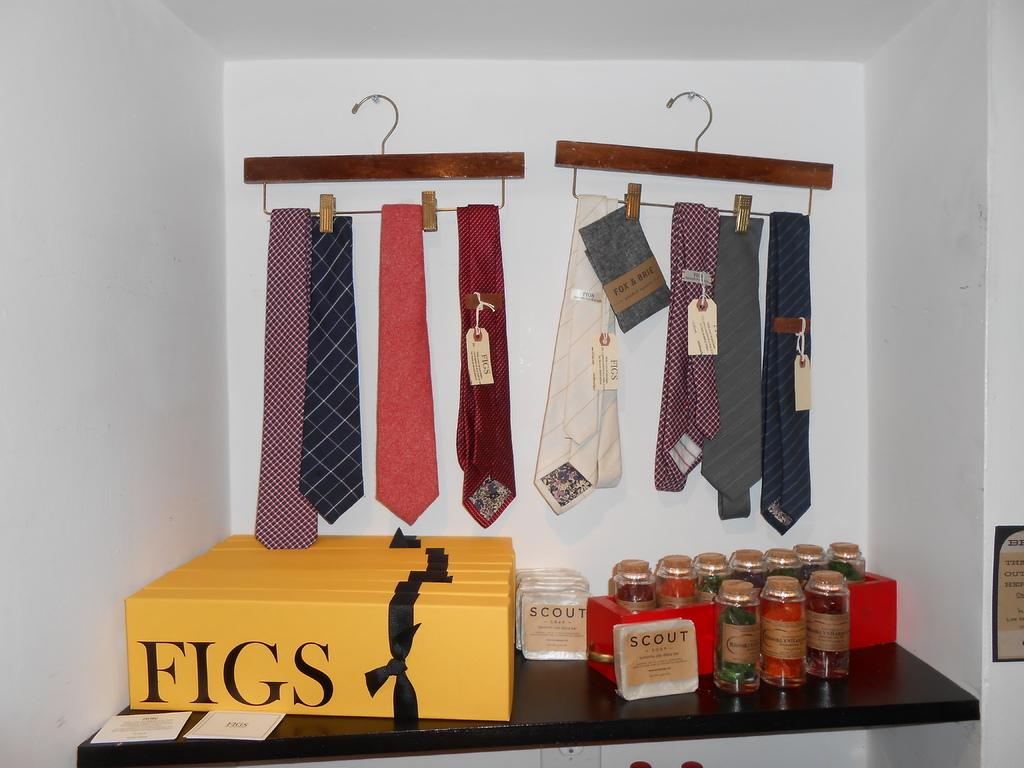<image>
Write a terse but informative summary of the picture. A collection of ties and different colored bottles with the brand Scout on them. 